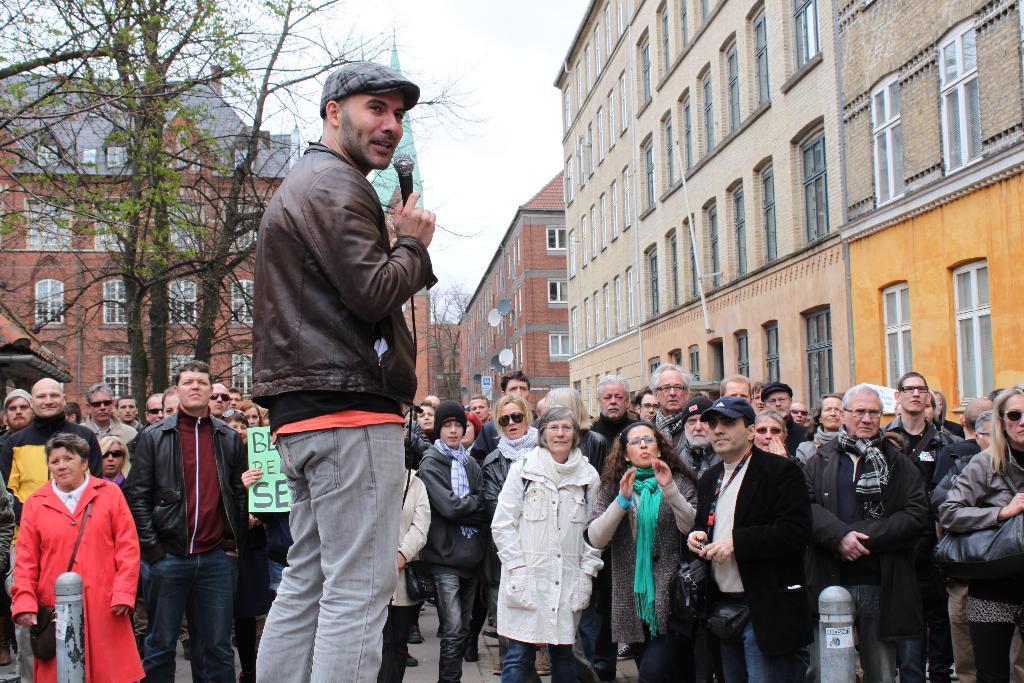In one or two sentences, can you explain what this image depicts? In this image we can see there are people standing on the ground and there is an another person holding a microphone. And there are buildings, poles, trees and the sky. 